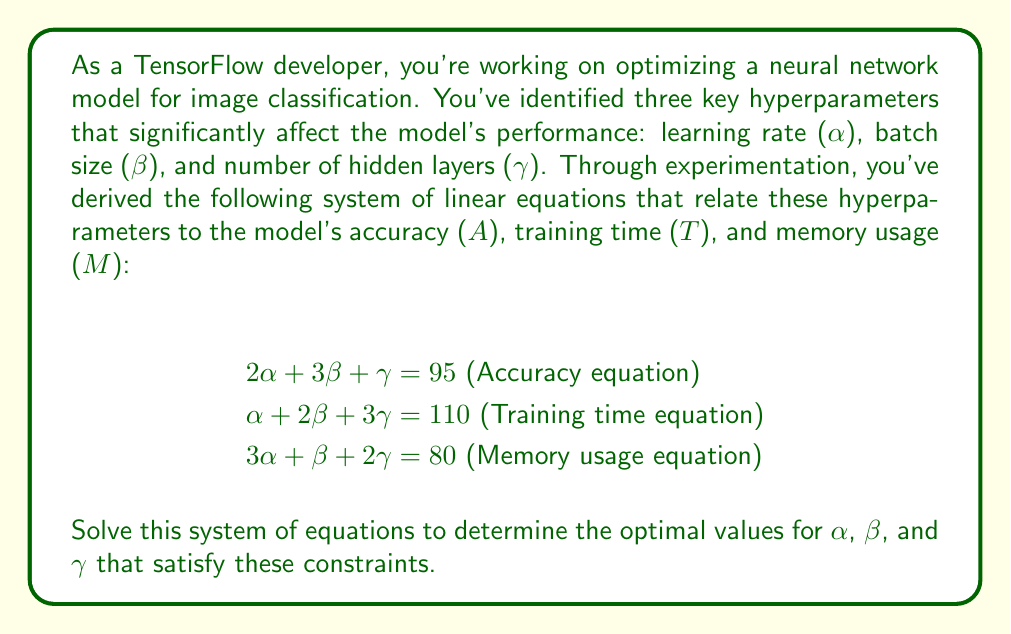Provide a solution to this math problem. To solve this system of linear equations, we'll use the Gaussian elimination method:

1) First, let's write the augmented matrix for this system:

   $$\begin{bmatrix}
   2 & 3 & 1 & 95 \\
   1 & 2 & 3 & 110 \\
   3 & 1 & 2 & 80
   \end{bmatrix}$$

2) We'll use the first equation to eliminate $\alpha$ from the second and third equations:
   
   R2 = R2 - 1/2 * R1
   R3 = R3 - 3/2 * R1

   $$\begin{bmatrix}
   2 & 3 & 1 & 95 \\
   0 & 1/2 & 5/2 & 62.5 \\
   0 & -7/2 & 1/2 & -62.5
   \end{bmatrix}$$

3) Now, we'll use the second row to eliminate $\beta$ from the third row:
   
   R3 = R3 + 7 * R2

   $$\begin{bmatrix}
   2 & 3 & 1 & 95 \\
   0 & 1/2 & 5/2 & 62.5 \\
   0 & 0 & 18 & 375
   \end{bmatrix}$$

4) From the third row, we can now solve for $\gamma$:

   $18\gamma = 375$
   $\gamma = \frac{375}{18} = 20.83333...$

5) Substituting this value into the second row:

   $\frac{1}{2}\beta + \frac{5}{2}(20.83333...) = 62.5$
   $\frac{1}{2}\beta + 52.08333... = 62.5$
   $\frac{1}{2}\beta = 10.41666...$
   $\beta = 20.83333...$

6) Finally, substituting these values into the first row:

   $2\alpha + 3(20.83333...) + 20.83333... = 95$
   $2\alpha + 83.33333... = 95$
   $2\alpha = 11.66666...$
   $\alpha = 5.83333...$

Therefore, the optimal values for the hyperparameters are:
$\alpha \approx 5.83$, $\beta \approx 20.83$, and $\gamma \approx 20.83$
Answer: $\alpha \approx 5.83$ (learning rate)
$\beta \approx 20.83$ (batch size)
$\gamma \approx 20.83$ (number of hidden layers) 